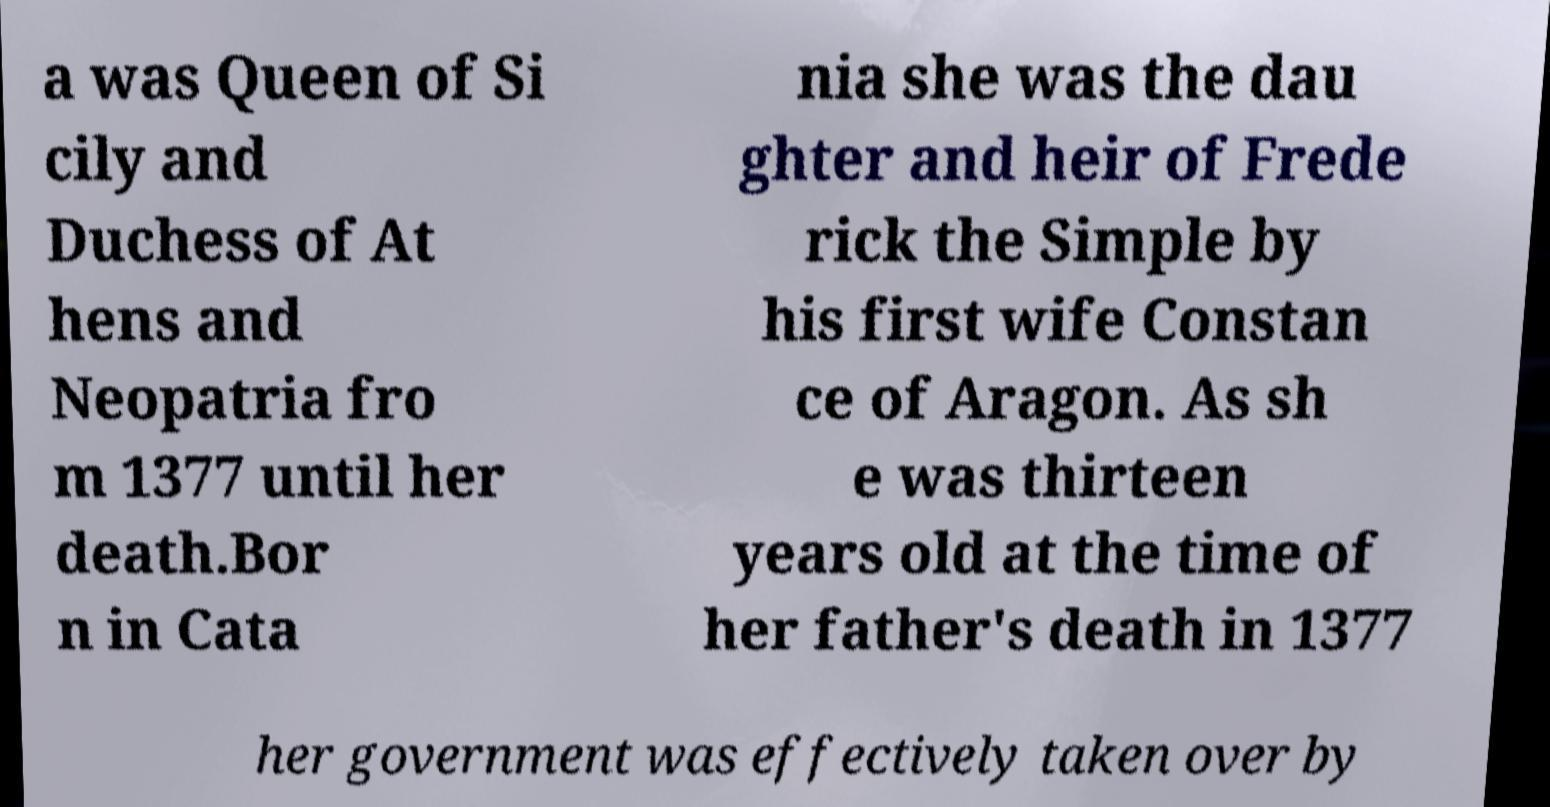Could you assist in decoding the text presented in this image and type it out clearly? a was Queen of Si cily and Duchess of At hens and Neopatria fro m 1377 until her death.Bor n in Cata nia she was the dau ghter and heir of Frede rick the Simple by his first wife Constan ce of Aragon. As sh e was thirteen years old at the time of her father's death in 1377 her government was effectively taken over by 